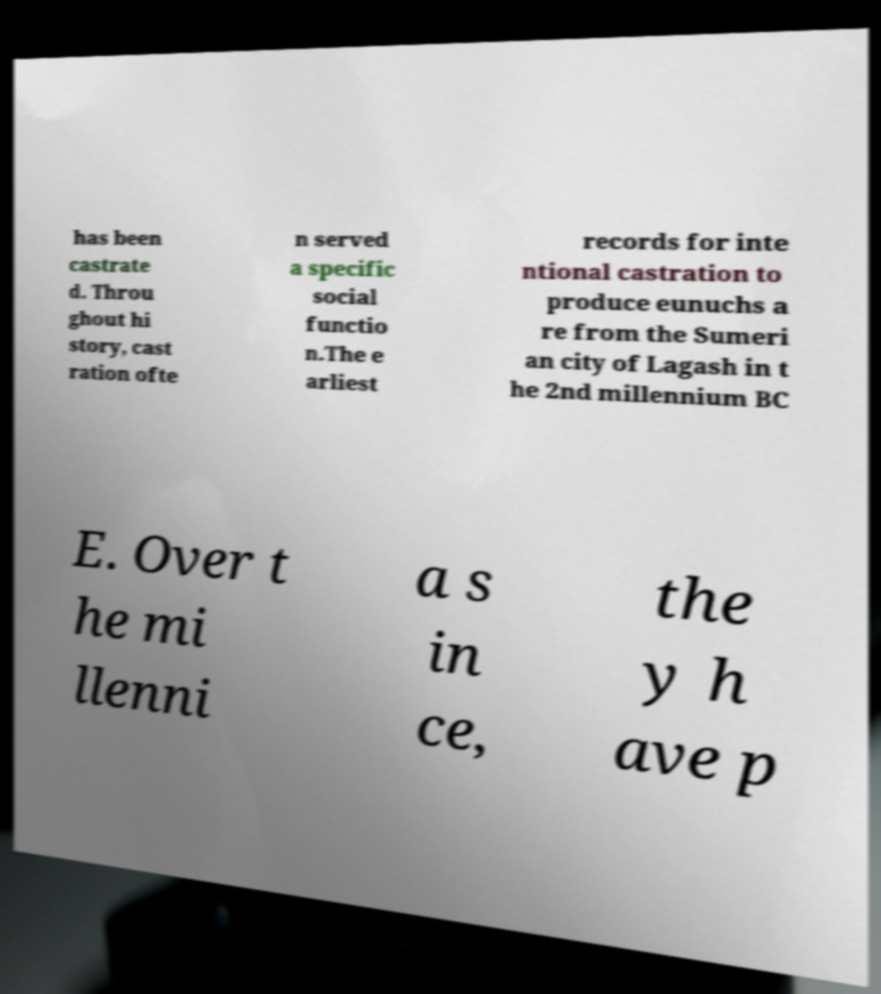Could you assist in decoding the text presented in this image and type it out clearly? has been castrate d. Throu ghout hi story, cast ration ofte n served a specific social functio n.The e arliest records for inte ntional castration to produce eunuchs a re from the Sumeri an city of Lagash in t he 2nd millennium BC E. Over t he mi llenni a s in ce, the y h ave p 